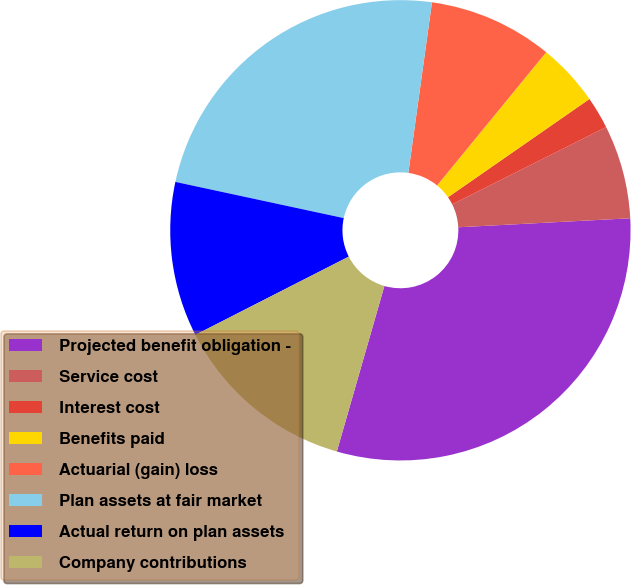<chart> <loc_0><loc_0><loc_500><loc_500><pie_chart><fcel>Projected benefit obligation -<fcel>Service cost<fcel>Interest cost<fcel>Benefits paid<fcel>Actuarial (gain) loss<fcel>Plan assets at fair market<fcel>Actual return on plan assets<fcel>Company contributions<nl><fcel>30.29%<fcel>6.57%<fcel>2.26%<fcel>4.42%<fcel>8.73%<fcel>23.82%<fcel>10.88%<fcel>13.04%<nl></chart> 